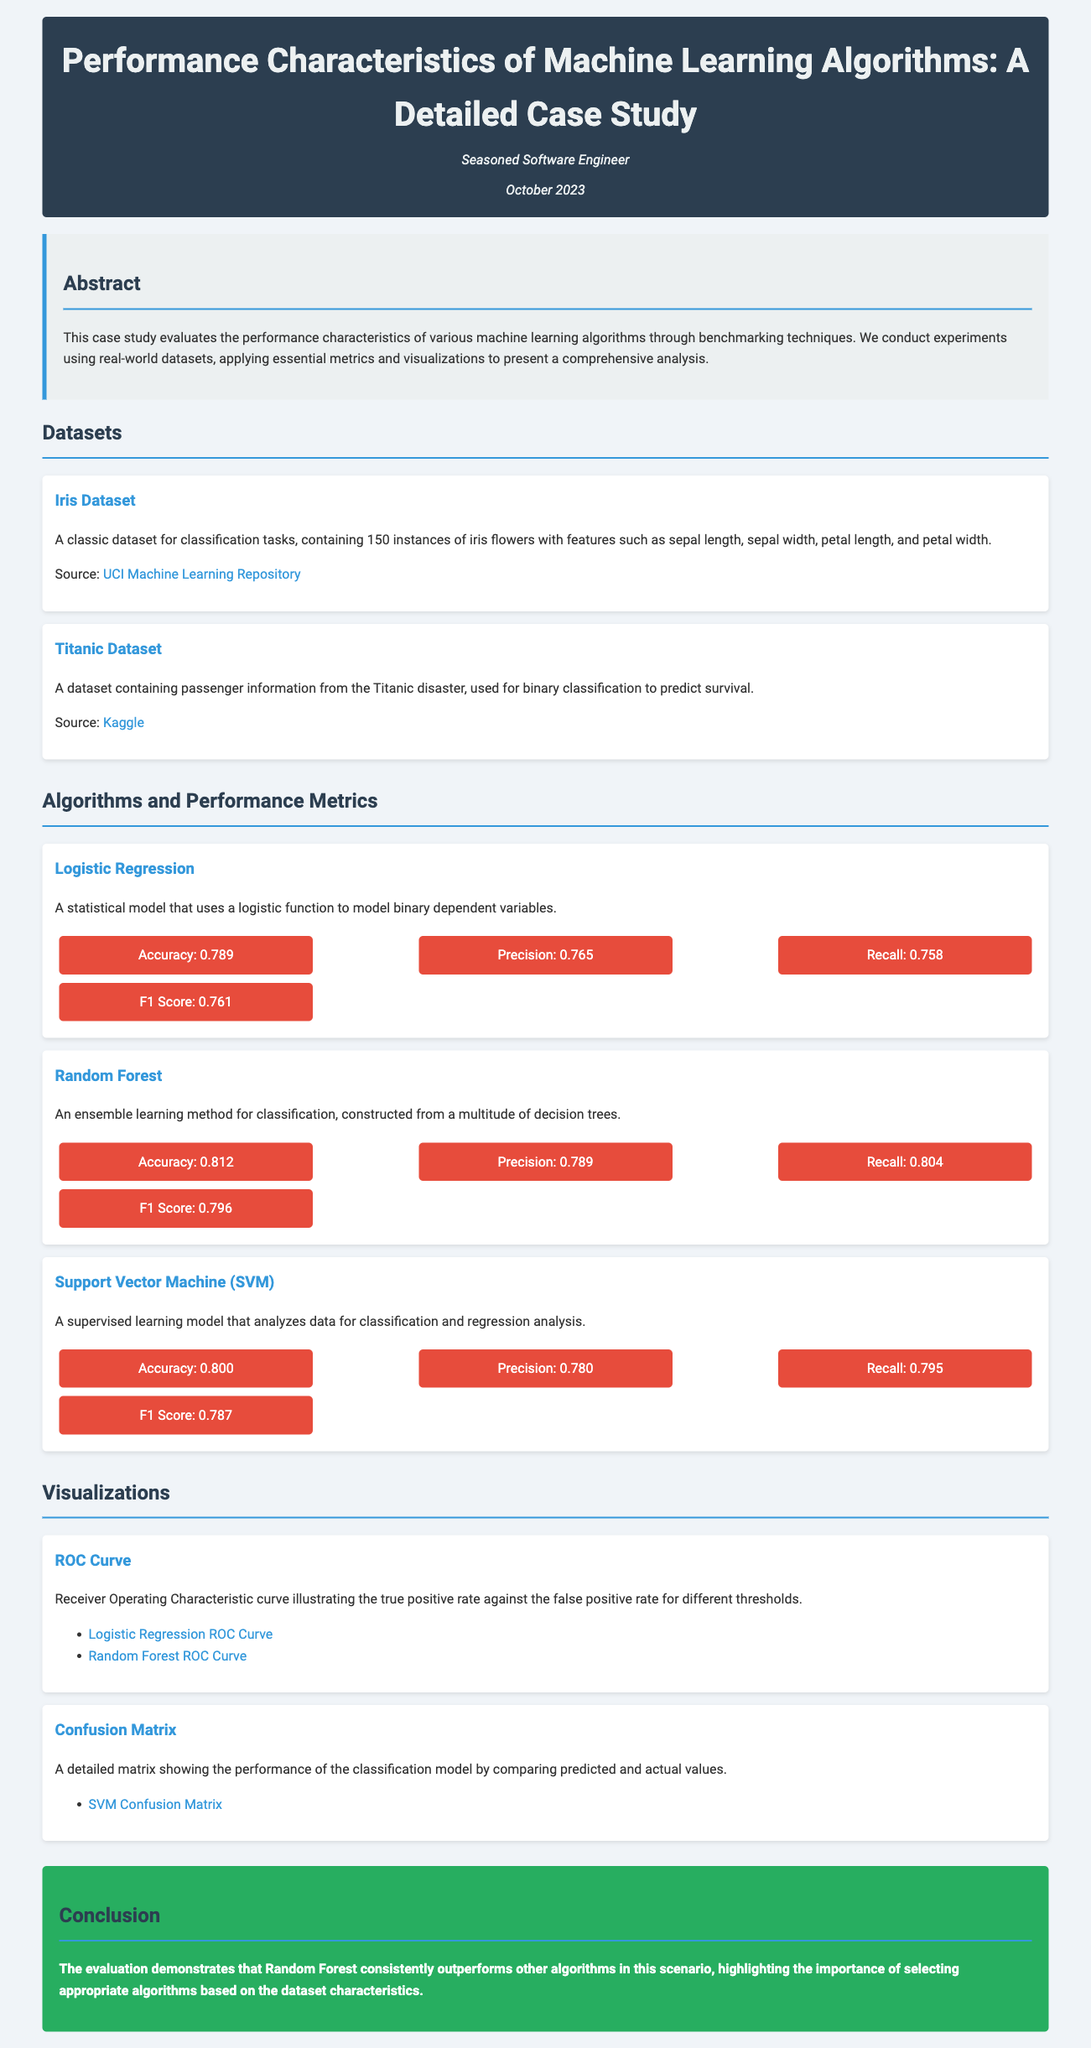What is the title of the case study? The title of the case study is included in the header of the document.
Answer: Performance Characteristics of Machine Learning Algorithms: A Detailed Case Study Who is the author of the document? The author of the document is mentioned right below the title in the header.
Answer: Seasoned Software Engineer When was the document published? The publication date is displayed under the author's name in the header section.
Answer: October 2023 What is the accuracy of the Random Forest algorithm? The accuracy metric for Random Forest is detailed in the Algorithms and Performance Metrics section.
Answer: 0.812 Which dataset is used for binary classification in the case study? The specific dataset used for binary classification is mentioned in the Datasets section.
Answer: Titanic Dataset Which algorithm has the highest F1 Score? The F1 Score of various algorithms is compared in the Algorithms and Performance Metrics section.
Answer: Random Forest What type of visualization is included in the document? Visualizations are detailed under the Visualizations section, specifying their types.
Answer: ROC Curve What is the conclusion regarding the performance of Random Forest? The conclusion summarizes the findings related to algorithm performance in the conclusion section.
Answer: Outperforms other algorithms 